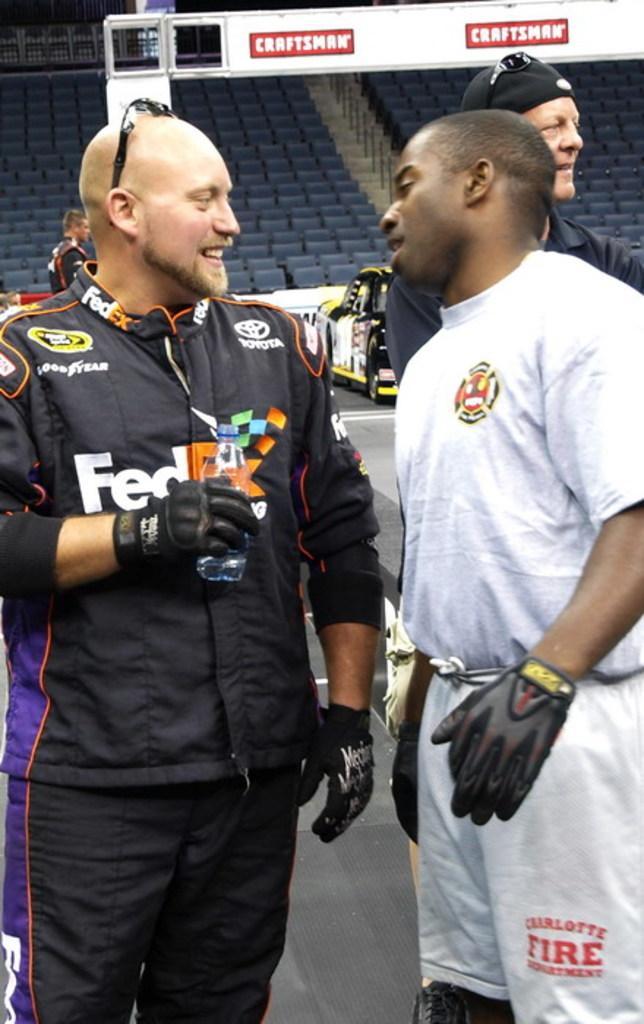Please provide a concise description of this image. In the picture we can see two men are standing on the floor and they are in sports wearing and looking at each other and smiling and in the background we can see full of chairs which are blue in color. 